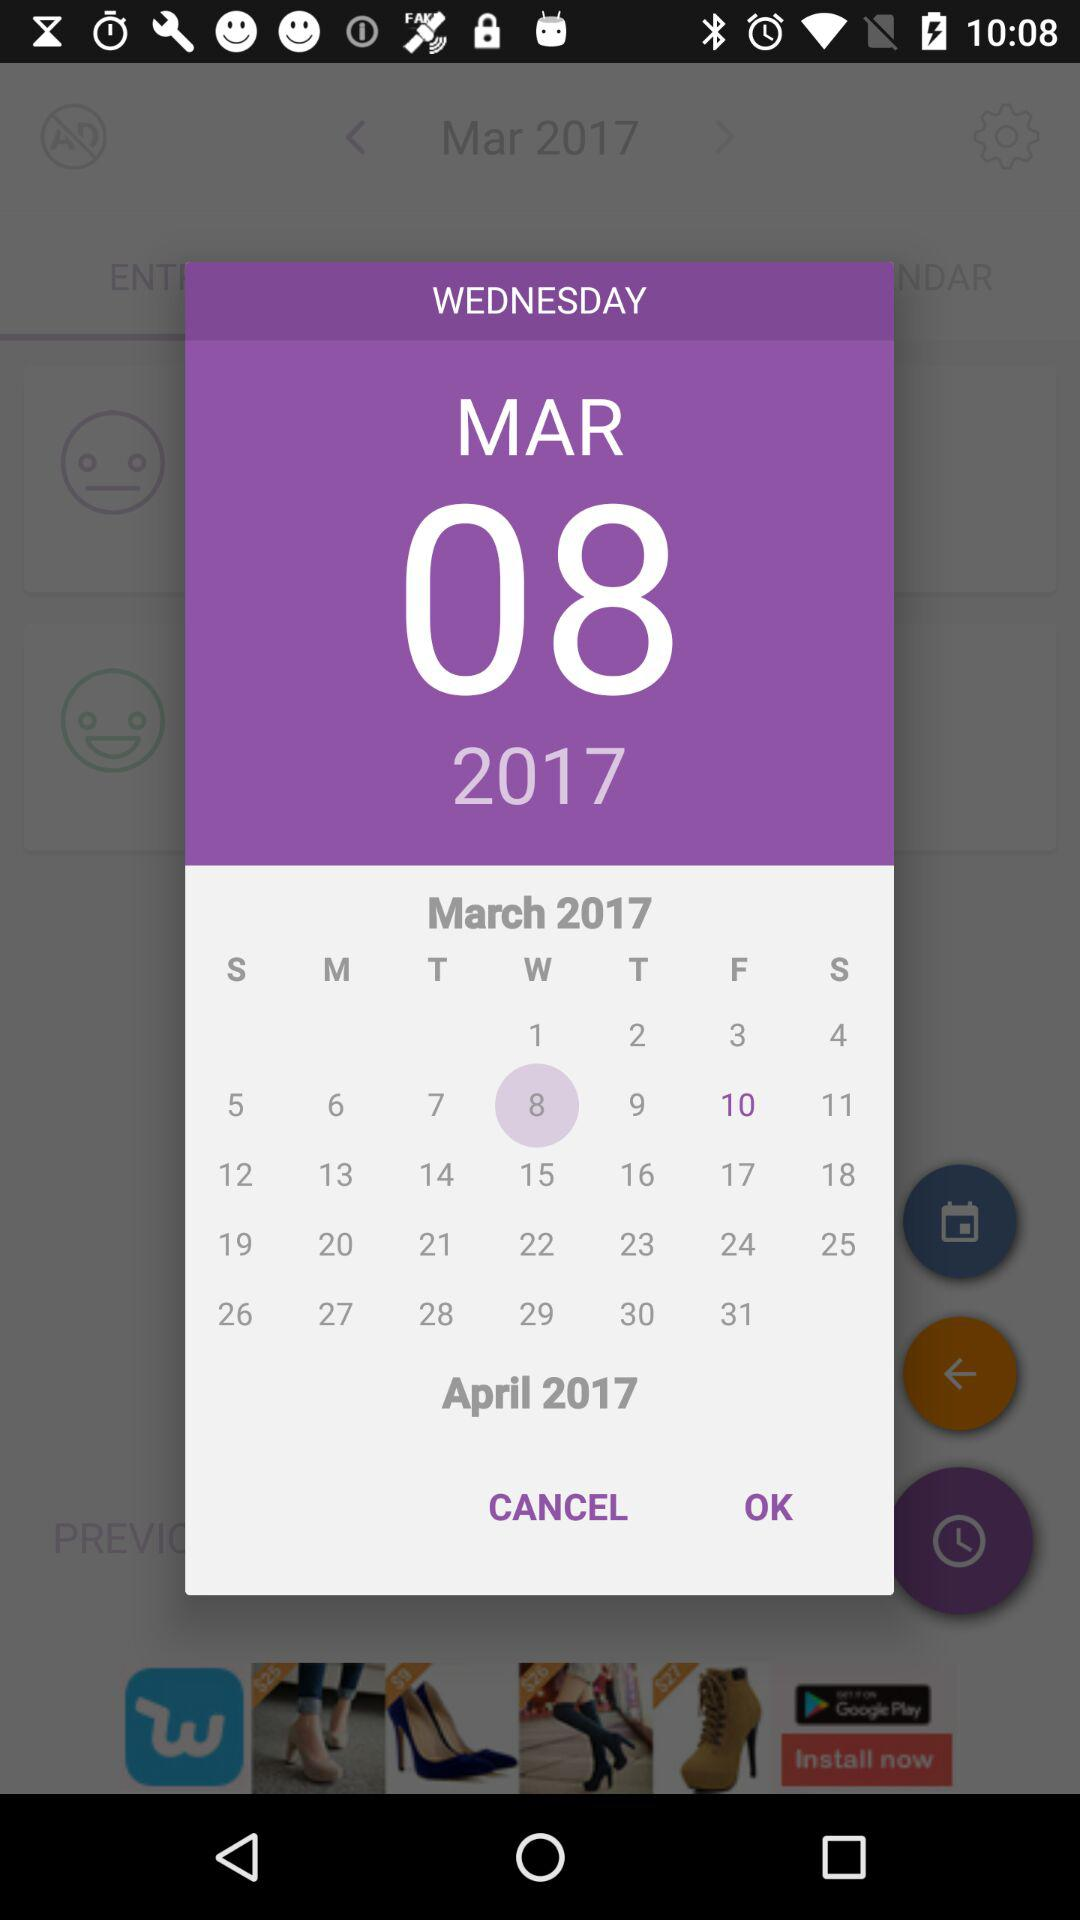What's the selected date? The selected date is Wednesday, March 8, 2017. 